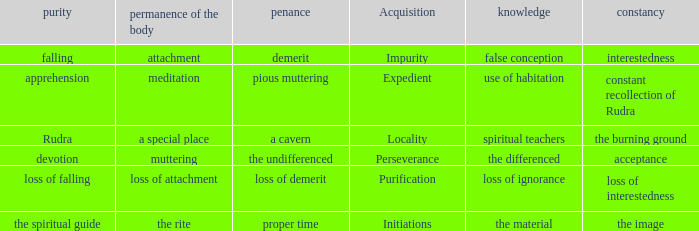What is the total number of constancy where purity is falling 1.0. 